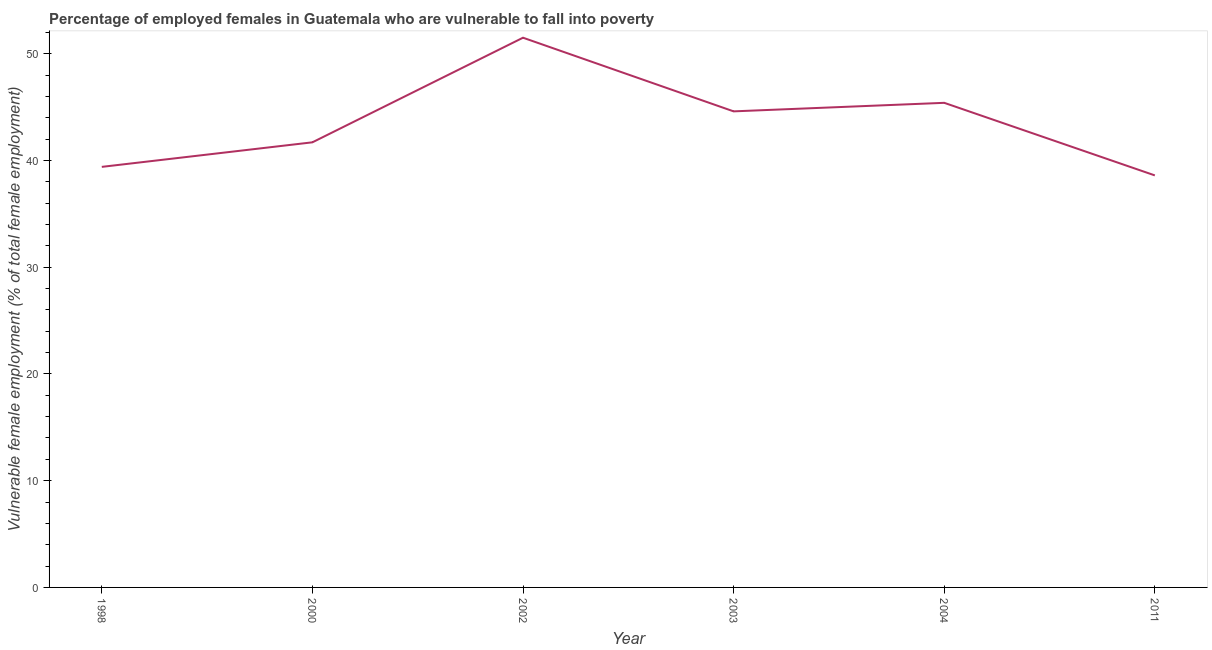What is the percentage of employed females who are vulnerable to fall into poverty in 2002?
Give a very brief answer. 51.5. Across all years, what is the maximum percentage of employed females who are vulnerable to fall into poverty?
Keep it short and to the point. 51.5. Across all years, what is the minimum percentage of employed females who are vulnerable to fall into poverty?
Keep it short and to the point. 38.6. In which year was the percentage of employed females who are vulnerable to fall into poverty maximum?
Provide a short and direct response. 2002. In which year was the percentage of employed females who are vulnerable to fall into poverty minimum?
Offer a very short reply. 2011. What is the sum of the percentage of employed females who are vulnerable to fall into poverty?
Provide a short and direct response. 261.2. What is the average percentage of employed females who are vulnerable to fall into poverty per year?
Make the answer very short. 43.53. What is the median percentage of employed females who are vulnerable to fall into poverty?
Offer a terse response. 43.15. What is the ratio of the percentage of employed females who are vulnerable to fall into poverty in 2003 to that in 2011?
Provide a succinct answer. 1.16. What is the difference between the highest and the second highest percentage of employed females who are vulnerable to fall into poverty?
Offer a very short reply. 6.1. What is the difference between the highest and the lowest percentage of employed females who are vulnerable to fall into poverty?
Keep it short and to the point. 12.9. How many lines are there?
Give a very brief answer. 1. What is the difference between two consecutive major ticks on the Y-axis?
Provide a short and direct response. 10. Are the values on the major ticks of Y-axis written in scientific E-notation?
Make the answer very short. No. What is the title of the graph?
Give a very brief answer. Percentage of employed females in Guatemala who are vulnerable to fall into poverty. What is the label or title of the X-axis?
Ensure brevity in your answer.  Year. What is the label or title of the Y-axis?
Ensure brevity in your answer.  Vulnerable female employment (% of total female employment). What is the Vulnerable female employment (% of total female employment) of 1998?
Provide a succinct answer. 39.4. What is the Vulnerable female employment (% of total female employment) in 2000?
Provide a succinct answer. 41.7. What is the Vulnerable female employment (% of total female employment) of 2002?
Your response must be concise. 51.5. What is the Vulnerable female employment (% of total female employment) of 2003?
Offer a very short reply. 44.6. What is the Vulnerable female employment (% of total female employment) of 2004?
Ensure brevity in your answer.  45.4. What is the Vulnerable female employment (% of total female employment) of 2011?
Keep it short and to the point. 38.6. What is the difference between the Vulnerable female employment (% of total female employment) in 1998 and 2000?
Make the answer very short. -2.3. What is the difference between the Vulnerable female employment (% of total female employment) in 1998 and 2002?
Give a very brief answer. -12.1. What is the difference between the Vulnerable female employment (% of total female employment) in 1998 and 2004?
Provide a short and direct response. -6. What is the difference between the Vulnerable female employment (% of total female employment) in 2000 and 2004?
Your response must be concise. -3.7. What is the difference between the Vulnerable female employment (% of total female employment) in 2000 and 2011?
Offer a terse response. 3.1. What is the difference between the Vulnerable female employment (% of total female employment) in 2002 and 2003?
Provide a short and direct response. 6.9. What is the difference between the Vulnerable female employment (% of total female employment) in 2002 and 2004?
Provide a short and direct response. 6.1. What is the difference between the Vulnerable female employment (% of total female employment) in 2002 and 2011?
Make the answer very short. 12.9. What is the difference between the Vulnerable female employment (% of total female employment) in 2003 and 2004?
Give a very brief answer. -0.8. What is the ratio of the Vulnerable female employment (% of total female employment) in 1998 to that in 2000?
Your answer should be compact. 0.94. What is the ratio of the Vulnerable female employment (% of total female employment) in 1998 to that in 2002?
Your answer should be very brief. 0.77. What is the ratio of the Vulnerable female employment (% of total female employment) in 1998 to that in 2003?
Give a very brief answer. 0.88. What is the ratio of the Vulnerable female employment (% of total female employment) in 1998 to that in 2004?
Your answer should be very brief. 0.87. What is the ratio of the Vulnerable female employment (% of total female employment) in 2000 to that in 2002?
Ensure brevity in your answer.  0.81. What is the ratio of the Vulnerable female employment (% of total female employment) in 2000 to that in 2003?
Give a very brief answer. 0.94. What is the ratio of the Vulnerable female employment (% of total female employment) in 2000 to that in 2004?
Provide a succinct answer. 0.92. What is the ratio of the Vulnerable female employment (% of total female employment) in 2002 to that in 2003?
Your response must be concise. 1.16. What is the ratio of the Vulnerable female employment (% of total female employment) in 2002 to that in 2004?
Provide a succinct answer. 1.13. What is the ratio of the Vulnerable female employment (% of total female employment) in 2002 to that in 2011?
Give a very brief answer. 1.33. What is the ratio of the Vulnerable female employment (% of total female employment) in 2003 to that in 2004?
Offer a terse response. 0.98. What is the ratio of the Vulnerable female employment (% of total female employment) in 2003 to that in 2011?
Your response must be concise. 1.16. What is the ratio of the Vulnerable female employment (% of total female employment) in 2004 to that in 2011?
Ensure brevity in your answer.  1.18. 